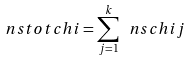Convert formula to latex. <formula><loc_0><loc_0><loc_500><loc_500>\ n s t o t c h i = \sum _ { j = 1 } ^ { k } \ n s c h i j</formula> 